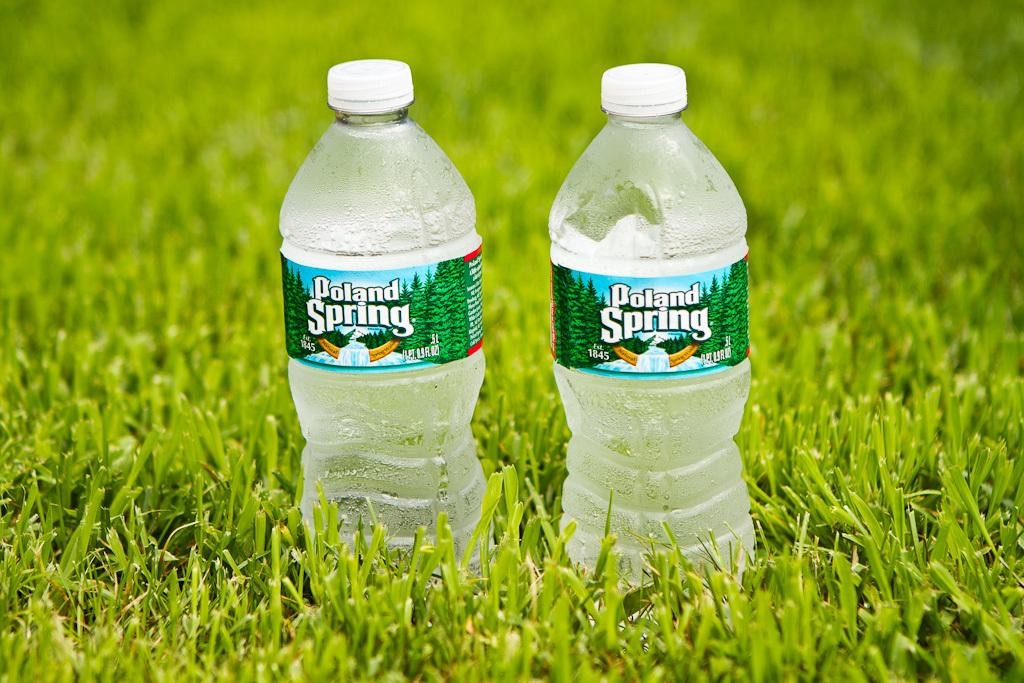What type of vegetation is visible in the image? There is grass in the image. What objects can be seen in the image besides the grass? There are two bottles visible in the image. What type of scent can be smelled coming from the grass in the image? There is no indication of a scent in the image, as it is a visual representation and does not include any olfactory information. 